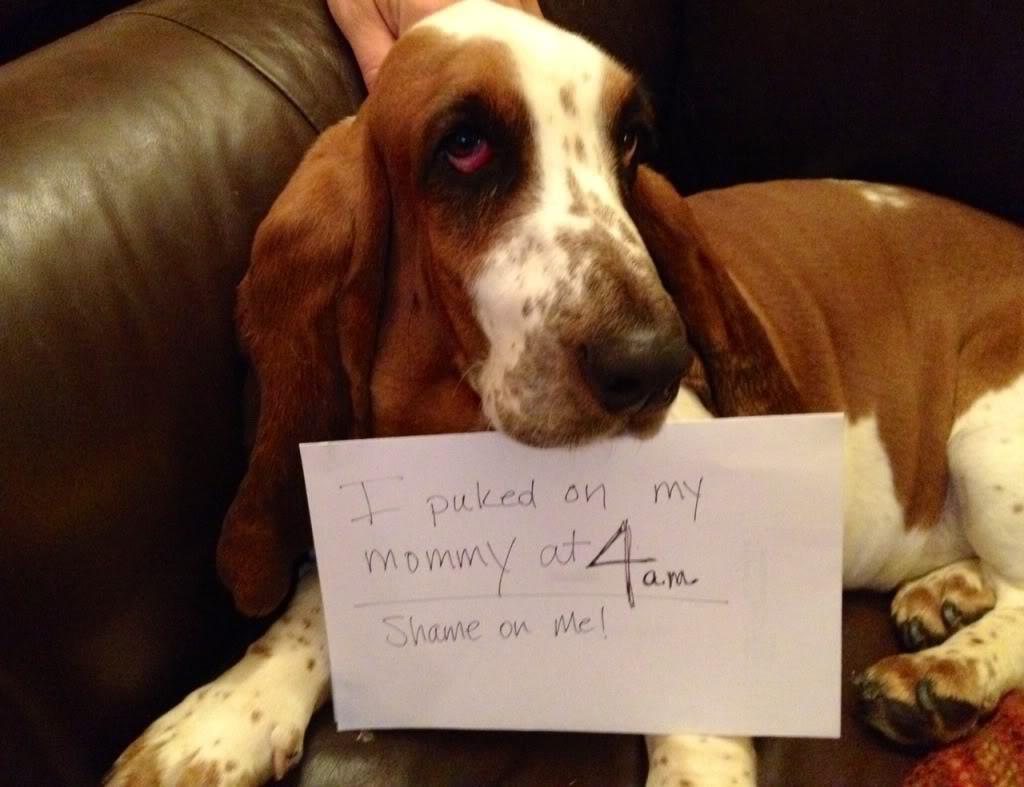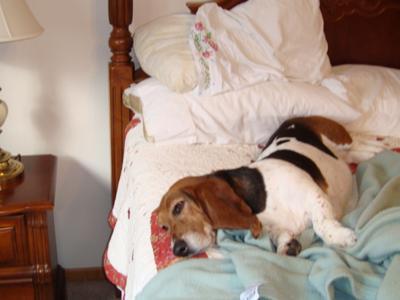The first image is the image on the left, the second image is the image on the right. Evaluate the accuracy of this statement regarding the images: "Two basset hounds snuggle together in a round pet bed, in one image.". Is it true? Answer yes or no. No. The first image is the image on the left, the second image is the image on the right. Examine the images to the left and right. Is the description "One image shows two adult basset hounds sleeping in a round dog bed together" accurate? Answer yes or no. No. 